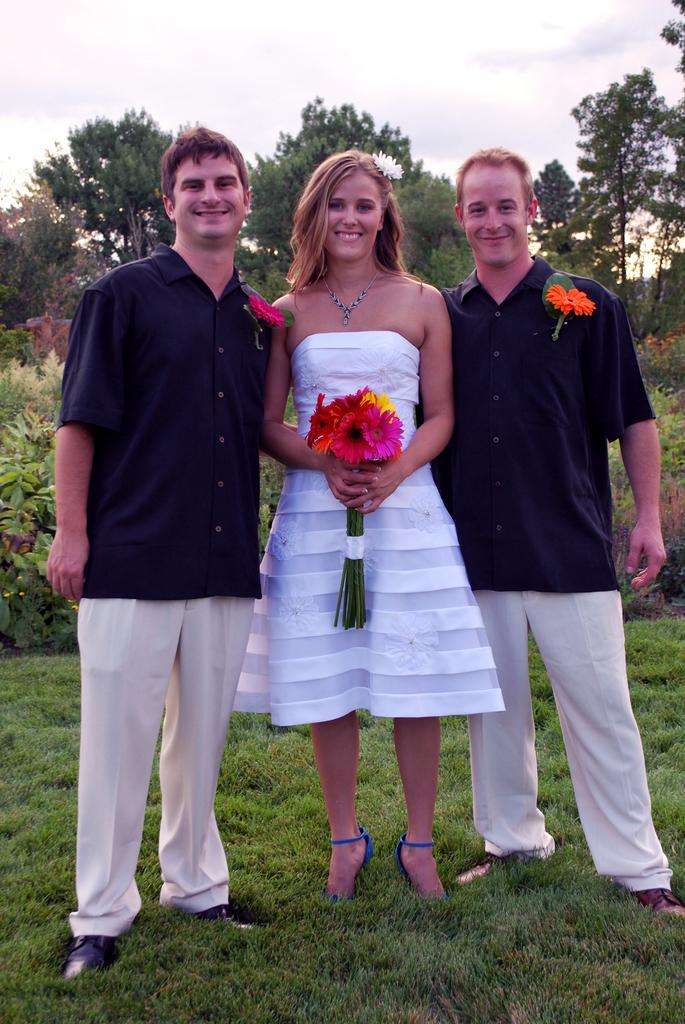Describe this image in one or two sentences. In this image in the middle there is a woman, she wears a dress, she is holding flowers. On the right there is a man, he wears a shirt, trouser, shoes, he is smiling. On the left there is a man, he wears a shirt, trouser, shoes, he is smiling. At the bottom there is grass. In the background there are plants, trees, sky and clouds. 